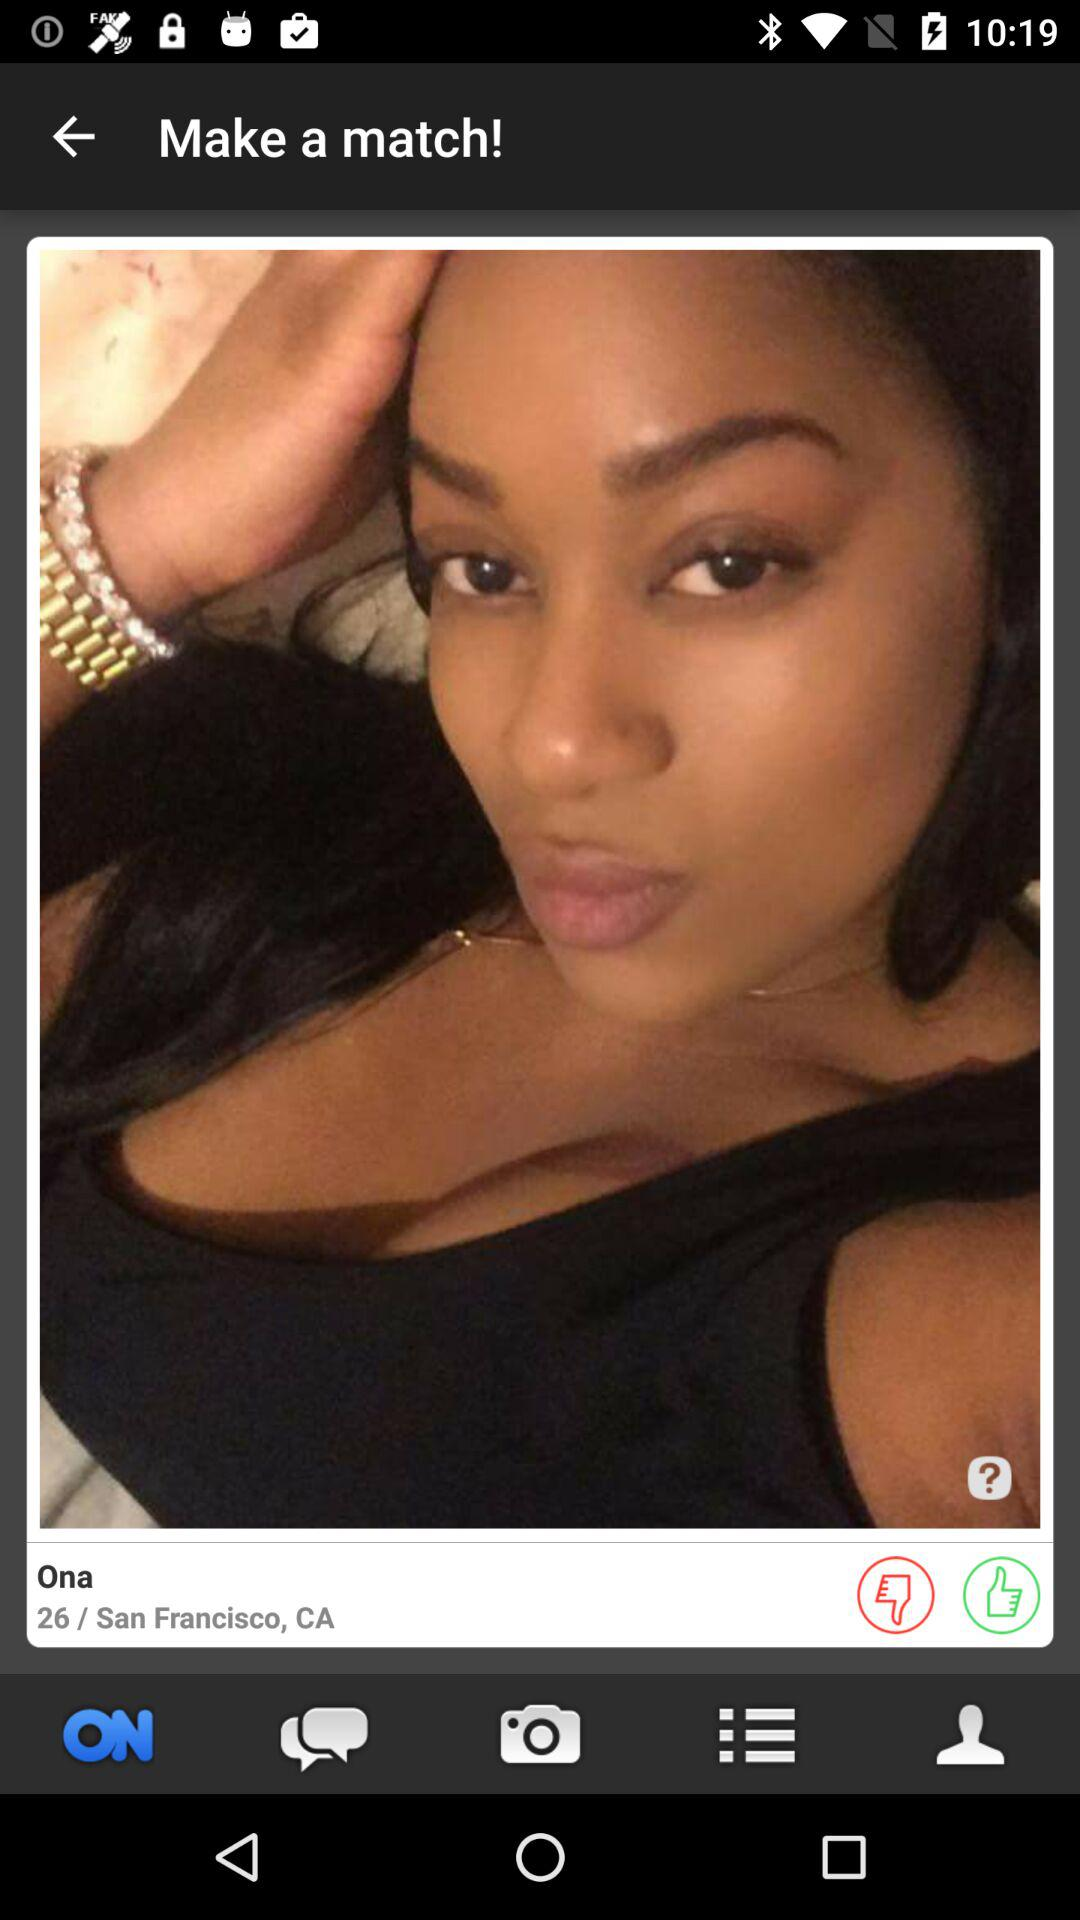What is the user name? The user name is Ona. 